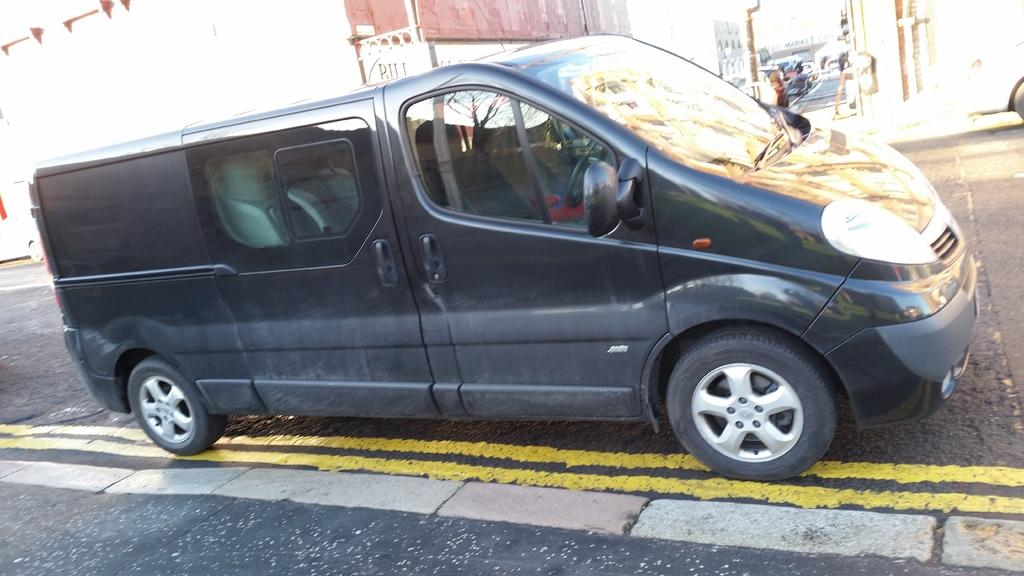What types of man-made structures can be seen in the image? There are buildings in the image. What else can be seen in the image besides buildings? There are vehicles, a board with text, and objects on the ground visible in the image. Can you describe the ground in the image? The ground is visible in the image. What objects can be found on the ground in the image? There are objects on the ground in the image. What is located in the top left corner of the image? There are objects in the top left corner of the image. Can you tell me how many verses are written on the rifle in the image? There is no rifle present in the image, and therefore no verses can be found on it. What type of cactus is growing in the top left corner of the image? There is no cactus present in the image; the objects in the top left corner are unrelated to plants. 